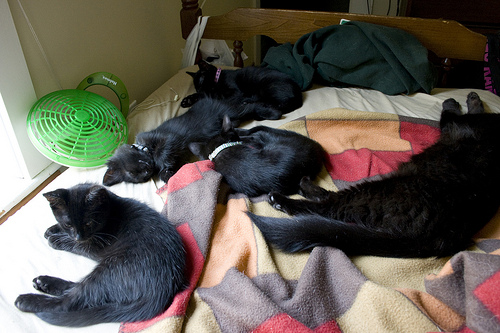<image>
Is the cat to the left of the cat? Yes. From this viewpoint, the cat is positioned to the left side relative to the cat. 